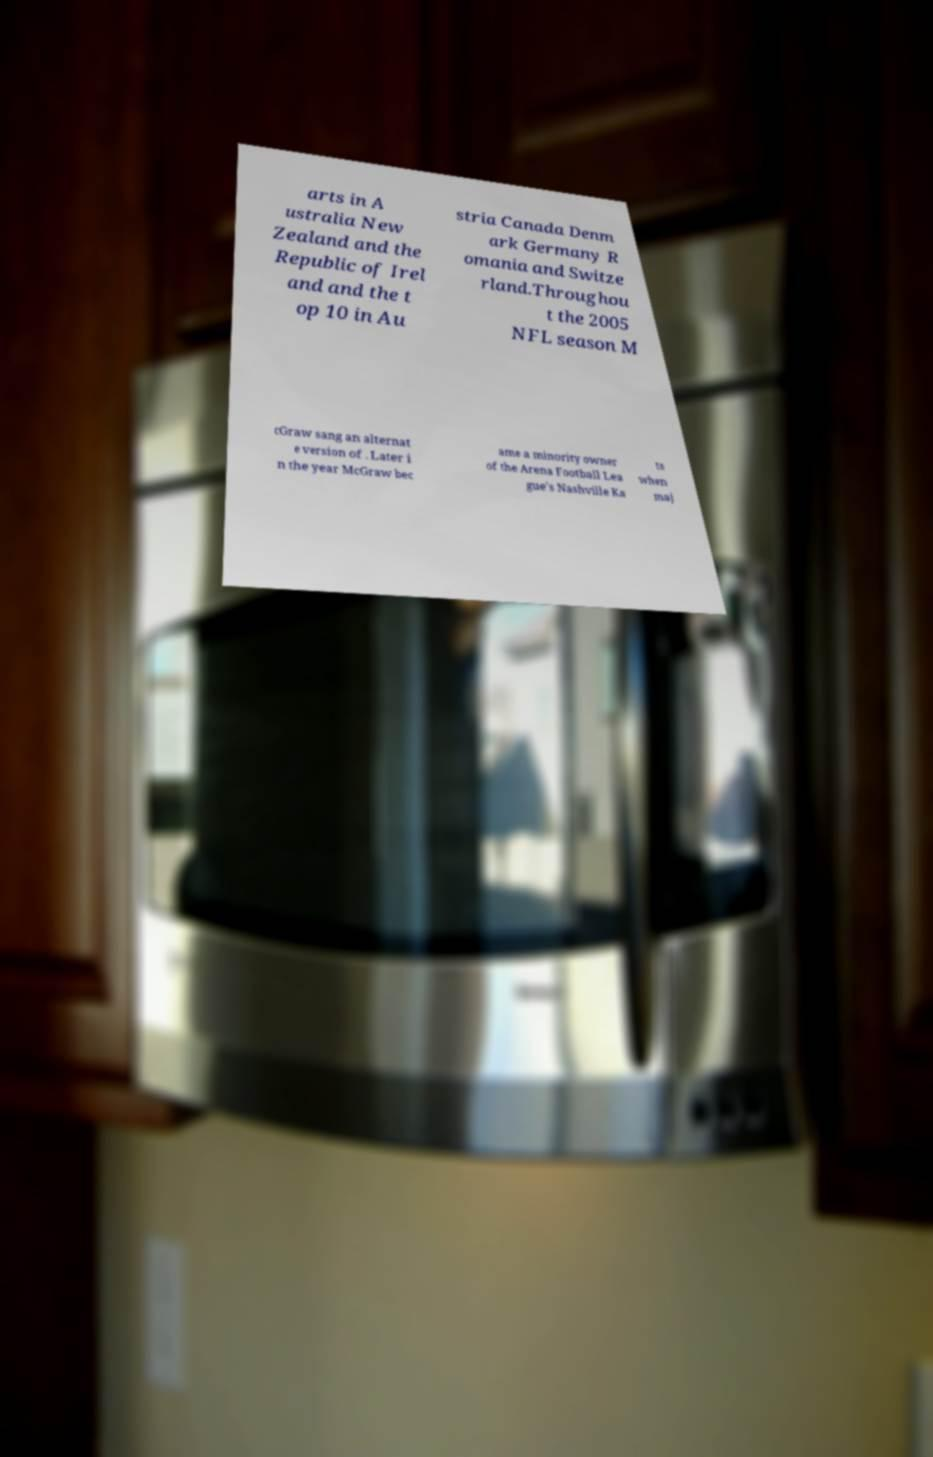Could you extract and type out the text from this image? arts in A ustralia New Zealand and the Republic of Irel and and the t op 10 in Au stria Canada Denm ark Germany R omania and Switze rland.Throughou t the 2005 NFL season M cGraw sang an alternat e version of . Later i n the year McGraw bec ame a minority owner of the Arena Football Lea gue's Nashville Ka ts when maj 